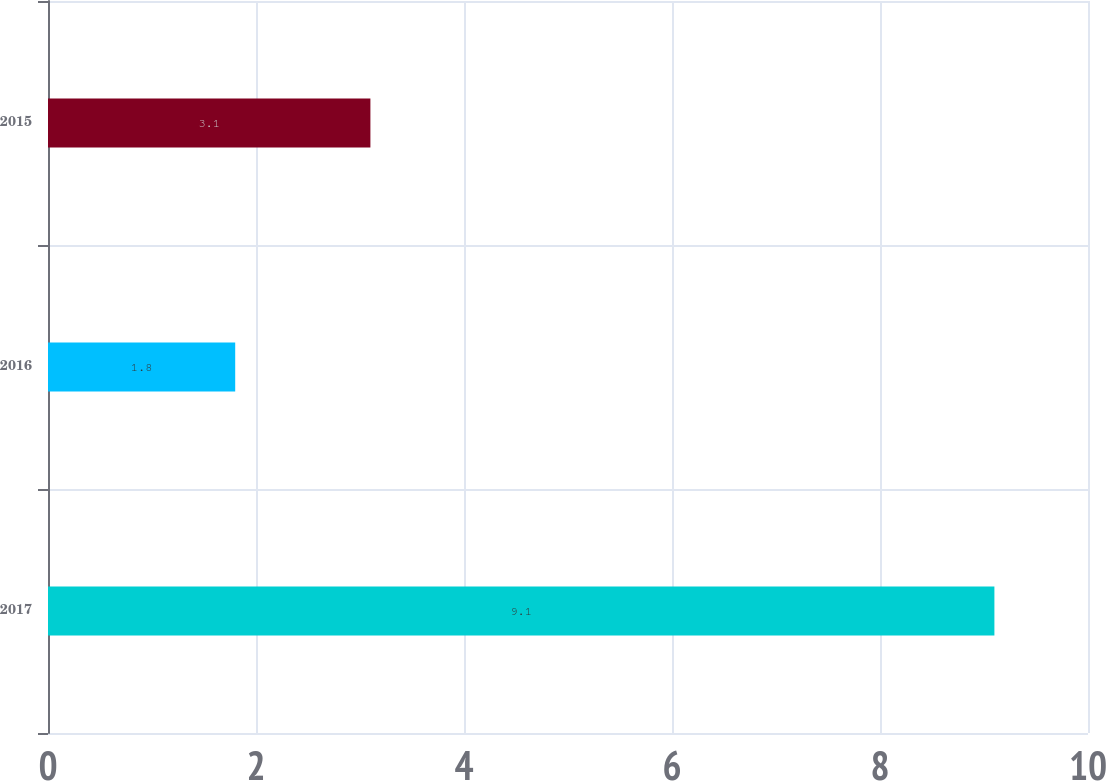Convert chart to OTSL. <chart><loc_0><loc_0><loc_500><loc_500><bar_chart><fcel>2017<fcel>2016<fcel>2015<nl><fcel>9.1<fcel>1.8<fcel>3.1<nl></chart> 